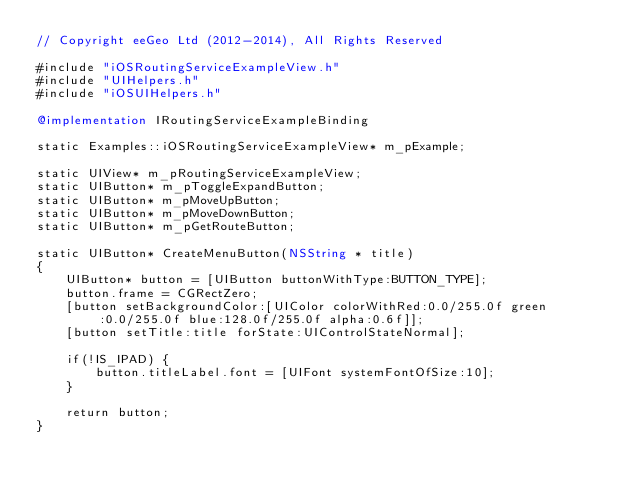<code> <loc_0><loc_0><loc_500><loc_500><_ObjectiveC_>// Copyright eeGeo Ltd (2012-2014), All Rights Reserved

#include "iOSRoutingServiceExampleView.h"
#include "UIHelpers.h"
#include "iOSUIHelpers.h"

@implementation IRoutingServiceExampleBinding

static Examples::iOSRoutingServiceExampleView* m_pExample;

static UIView* m_pRoutingServiceExampleView;
static UIButton* m_pToggleExpandButton;
static UIButton* m_pMoveUpButton;
static UIButton* m_pMoveDownButton;
static UIButton* m_pGetRouteButton;

static UIButton* CreateMenuButton(NSString * title)
{
    UIButton* button = [UIButton buttonWithType:BUTTON_TYPE];
    button.frame = CGRectZero;
    [button setBackgroundColor:[UIColor colorWithRed:0.0/255.0f green:0.0/255.0f blue:128.0f/255.0f alpha:0.6f]];
    [button setTitle:title forState:UIControlStateNormal];
    
    if(!IS_IPAD) {
        button.titleLabel.font = [UIFont systemFontOfSize:10];
    }
    
    return button;
}
</code> 